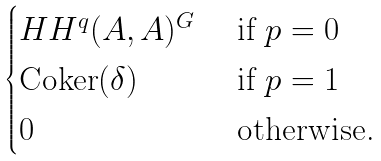Convert formula to latex. <formula><loc_0><loc_0><loc_500><loc_500>\begin{cases} H H ^ { q } ( A , A ) ^ { G } & \text { if } p = 0 \\ \text {Coker} ( \delta ) & \text { if } p = 1 \\ 0 & \text { otherwise.} \end{cases}</formula> 